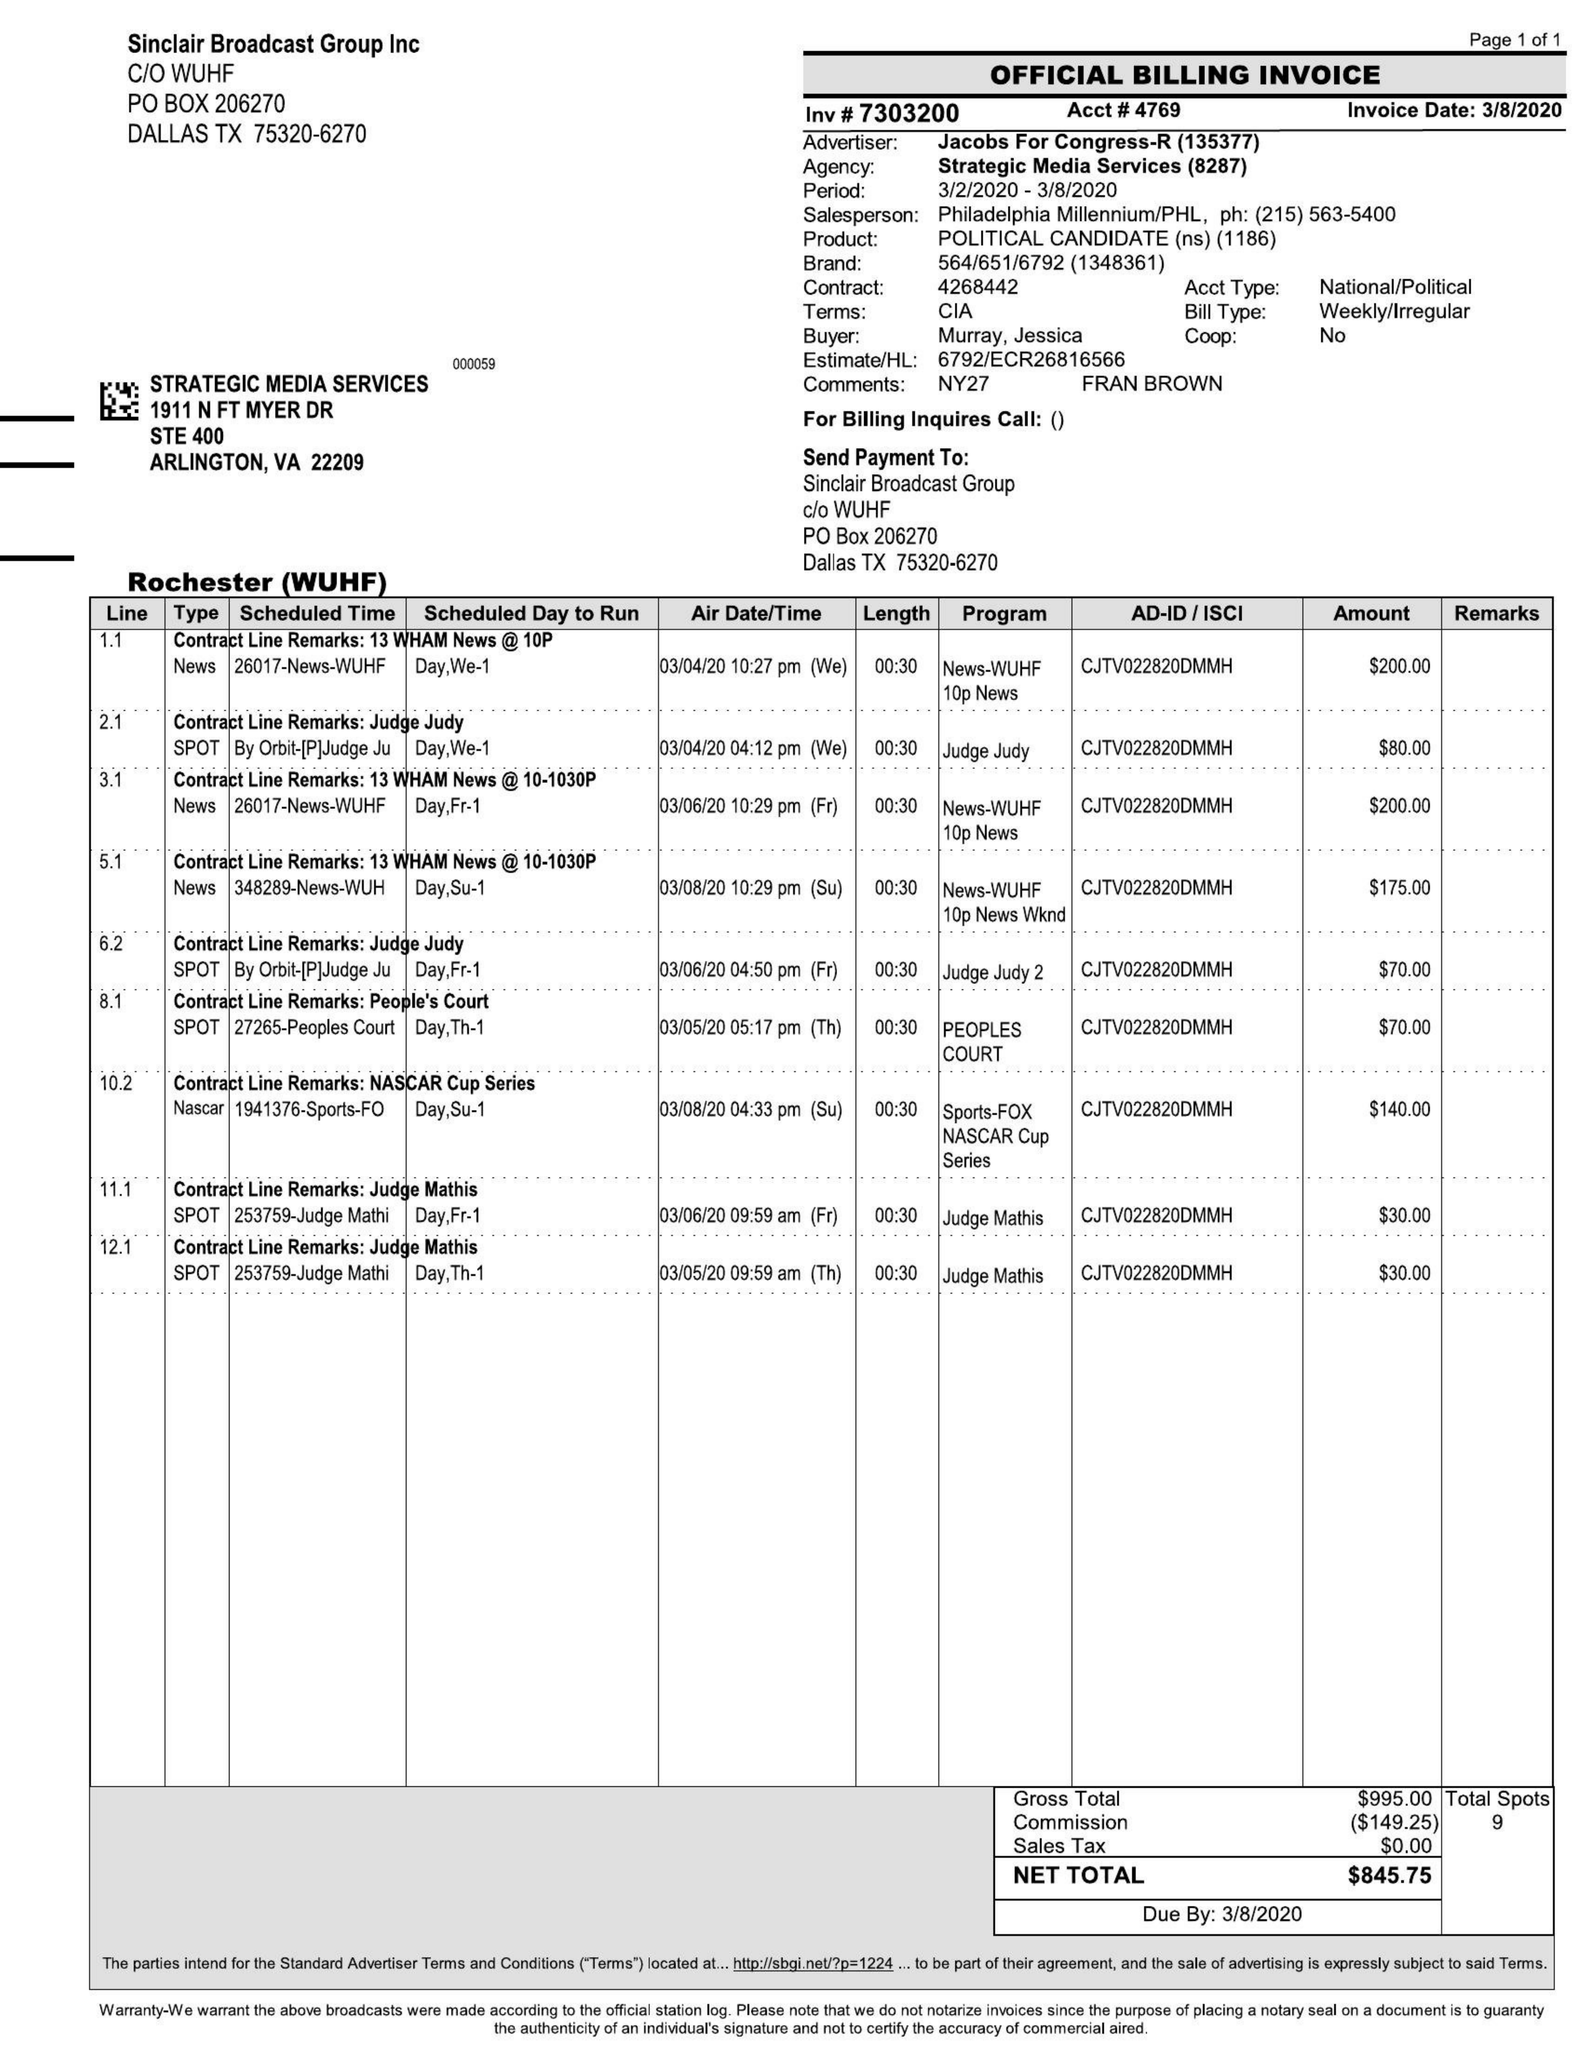What is the value for the contract_num?
Answer the question using a single word or phrase. 7303200 